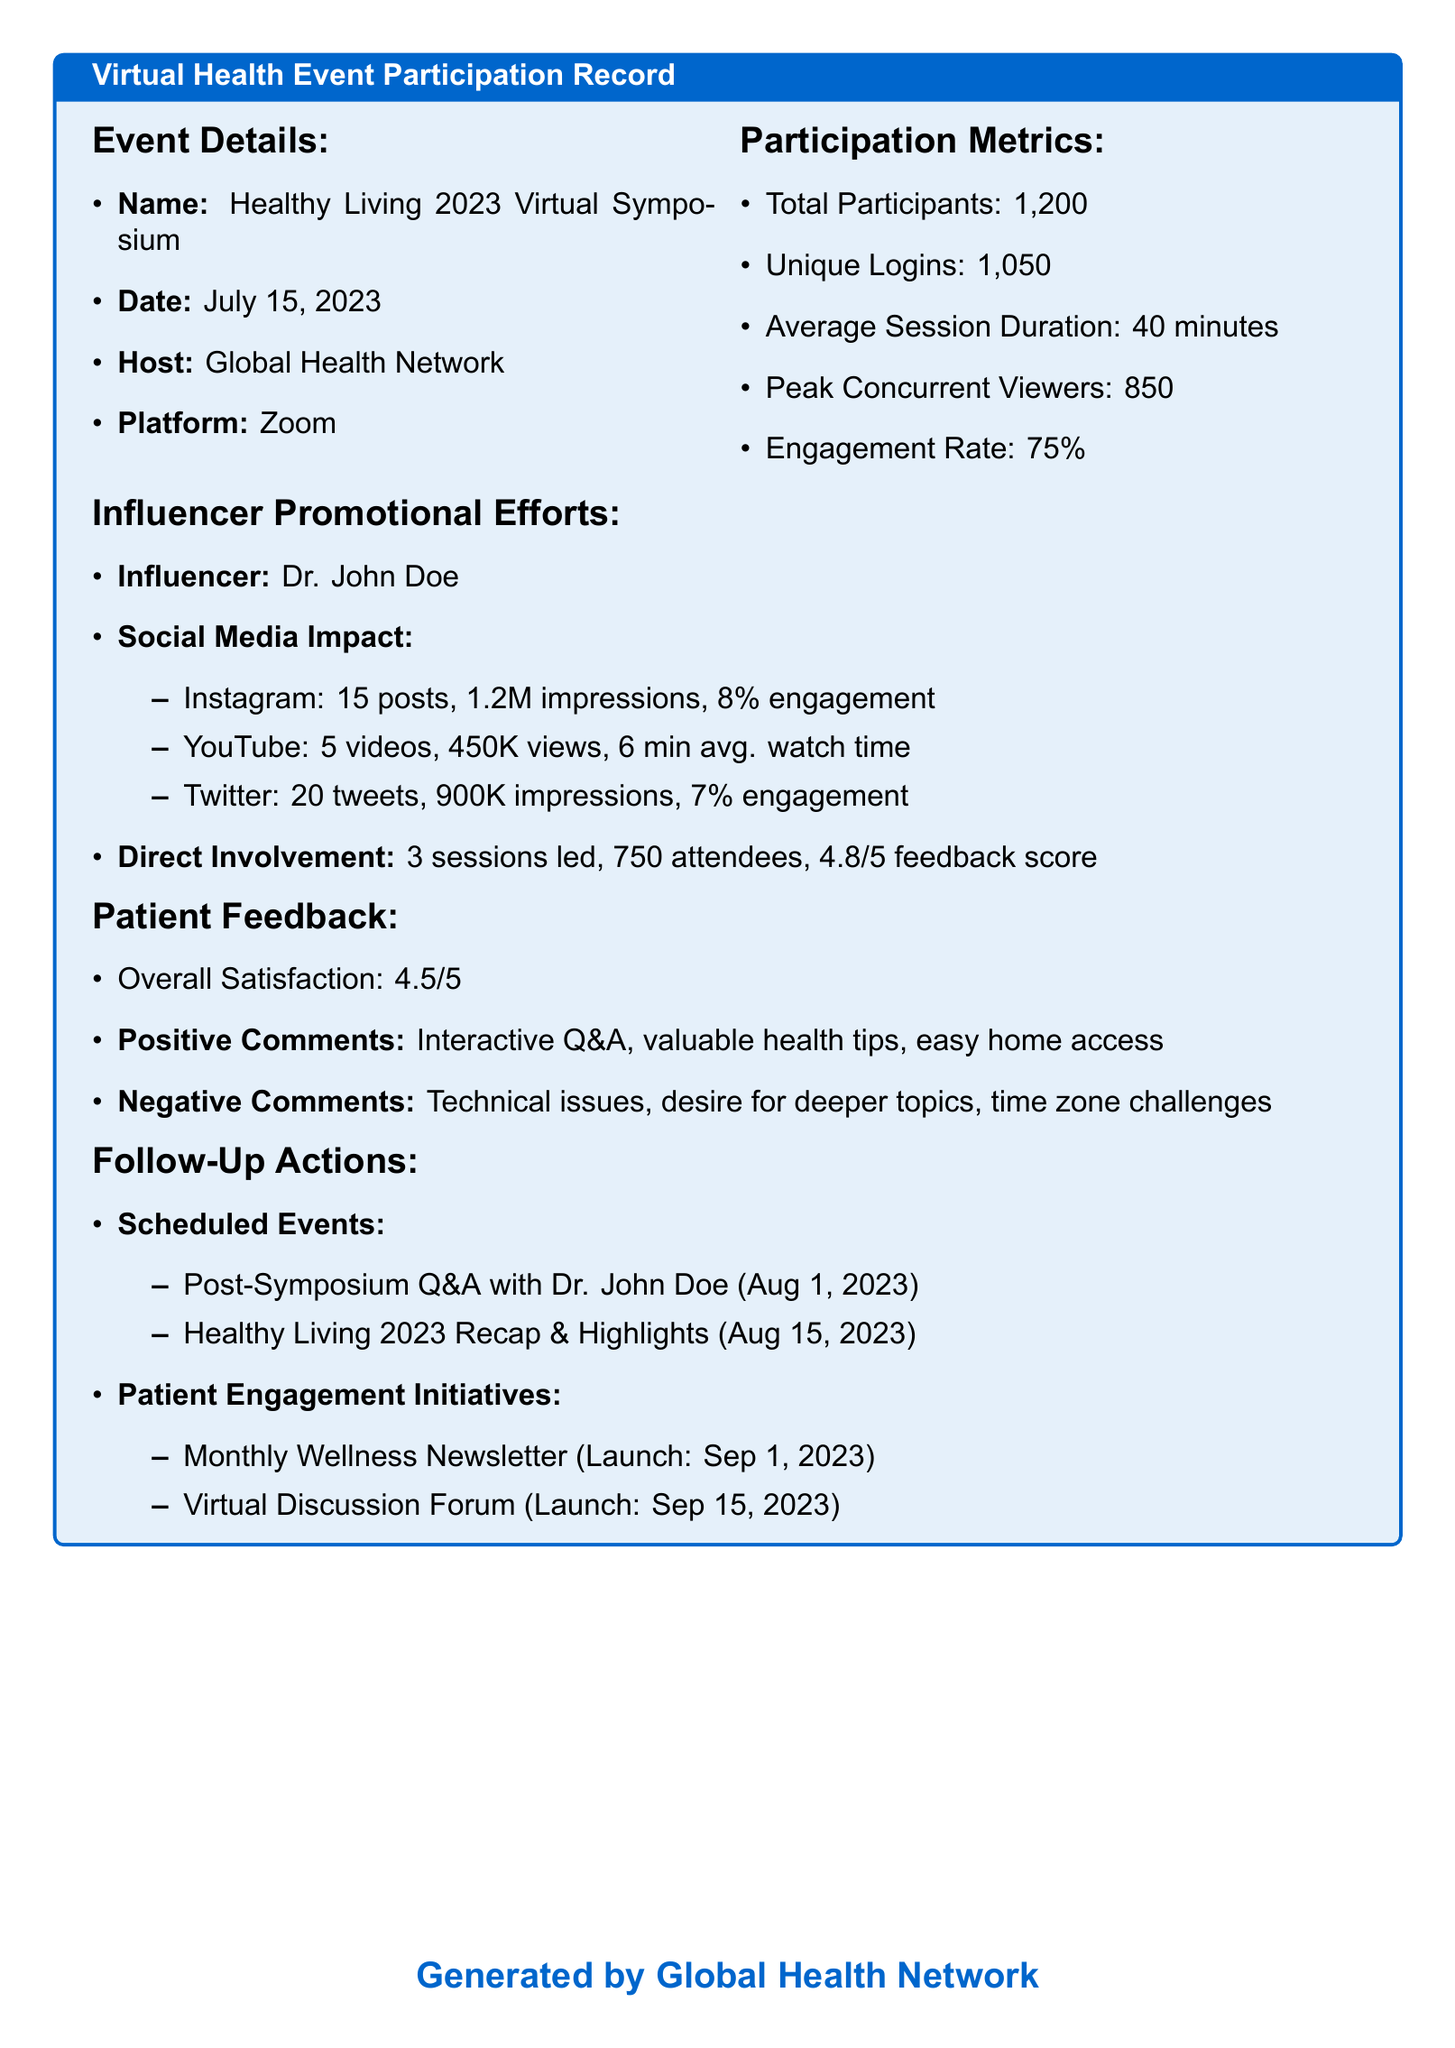What was the name of the event? The name of the event is provided in the document under Event Details.
Answer: Healthy Living 2023 Virtual Symposium Who hosted the event? The host of the event is mentioned in the document's Event Details section.
Answer: Global Health Network What was the peak concurrent viewers count? The document specifies the peak concurrent viewers in the Participation Metrics section.
Answer: 850 What was Dr. John Doe's feedback score for his sessions? The feedback score for Dr. John Doe's sessions is found in the Influencer Promotional Efforts section.
Answer: 4.8/5 How many unique logins were recorded? The number of unique logins is stated in the Participation Metrics section of the document.
Answer: 1,050 What is the overall satisfaction rating from patients? Overall satisfaction is provided in the Patient Feedback section of the document.
Answer: 4.5/5 How many sessions did Dr. John Doe lead? The number of sessions led by Dr. John Doe is listed in the Influencer Promotional Efforts.
Answer: 3 What date is the post-symposium Q&A scheduled for? The scheduled date for the post-symposium Q&A is detailed under Follow-Up Actions.
Answer: Aug 1, 2023 What platform was used for the virtual event? The platform for the event is described in the Event Details section.
Answer: Zoom 